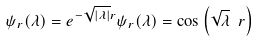Convert formula to latex. <formula><loc_0><loc_0><loc_500><loc_500>\psi _ { r } ( \lambda ) = e ^ { - \sqrt { | \lambda | } r } \psi _ { r } ( \lambda ) = \cos \left ( \sqrt { \lambda } \ r \right )</formula> 